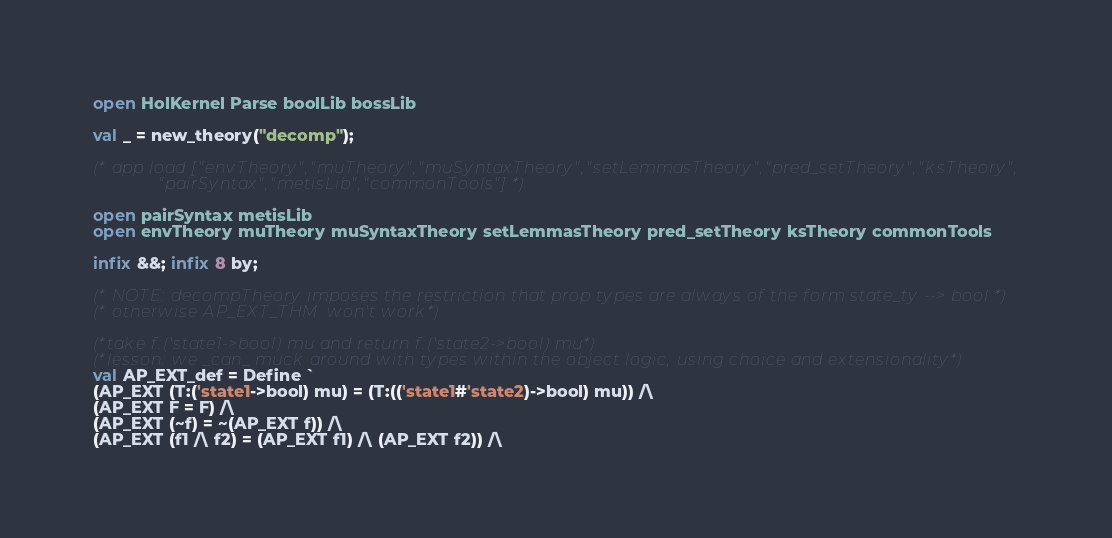<code> <loc_0><loc_0><loc_500><loc_500><_SML_>open HolKernel Parse boolLib bossLib

val _ = new_theory("decomp");

(* app load ["envTheory","muTheory","muSyntaxTheory","setLemmasTheory","pred_setTheory","ksTheory",
             "pairSyntax","metisLib","commonTools"] *)

open pairSyntax metisLib
open envTheory muTheory muSyntaxTheory setLemmasTheory pred_setTheory ksTheory commonTools

infix &&; infix 8 by;

(* NOTE: decompTheory imposes the restriction that prop types are always of the form state_ty --> bool *)
(* otherwise AP_EXT_THM  won't work*)

(*take f:('state1->bool) mu and return f:('state2->bool) mu*)
(*lesson: we _can_ muck around with types within the object logic, using choice and extensionality*)
val AP_EXT_def = Define `
(AP_EXT (T:('state1->bool) mu) = (T:(('state1#'state2)->bool) mu)) /\
(AP_EXT F = F) /\
(AP_EXT (~f) = ~(AP_EXT f)) /\
(AP_EXT (f1 /\ f2) = (AP_EXT f1) /\ (AP_EXT f2)) /\</code> 